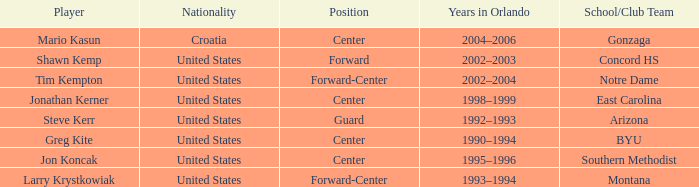In which years did orlando have participants with the united states nationality and montana as their school/club team? 1993–1994. 